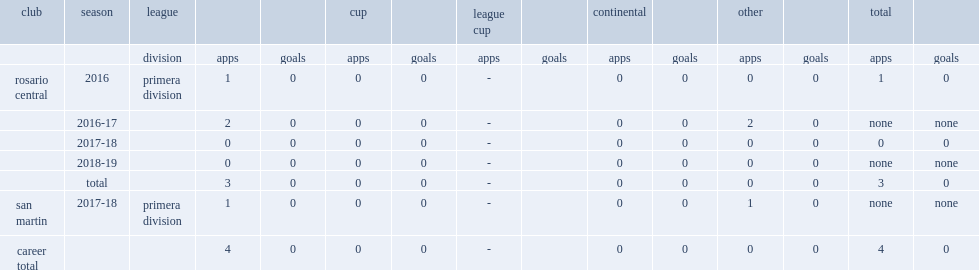In 2016, which league did felix banega make his debut with rosario central in? Primera division. 